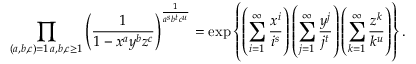<formula> <loc_0><loc_0><loc_500><loc_500>\prod _ { \substack { ( a , b , c ) = 1 \, a , b , c \geq 1 } } \left ( \frac { 1 } { 1 - x ^ { a } y ^ { b } z ^ { c } } \right ) ^ { \frac { 1 } { a ^ { s } b ^ { t } c ^ { u } } } = \exp \left \{ \left ( \sum _ { i = 1 } ^ { \infty } \frac { x ^ { i } } { i ^ { s } } \right ) \left ( \sum _ { j = 1 } ^ { \infty } \frac { y ^ { j } } { j ^ { t } } \right ) \left ( \sum _ { k = 1 } ^ { \infty } \frac { z ^ { k } } { k ^ { u } } \right ) \right \} .</formula> 